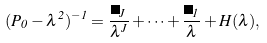<formula> <loc_0><loc_0><loc_500><loc_500>( P _ { 0 } - \lambda ^ { 2 } ) ^ { - 1 } = \frac { \Pi _ { J } } { \lambda ^ { J } } + \cdots + \frac { \Pi _ { 1 } } { \lambda } + H ( \lambda ) ,</formula> 